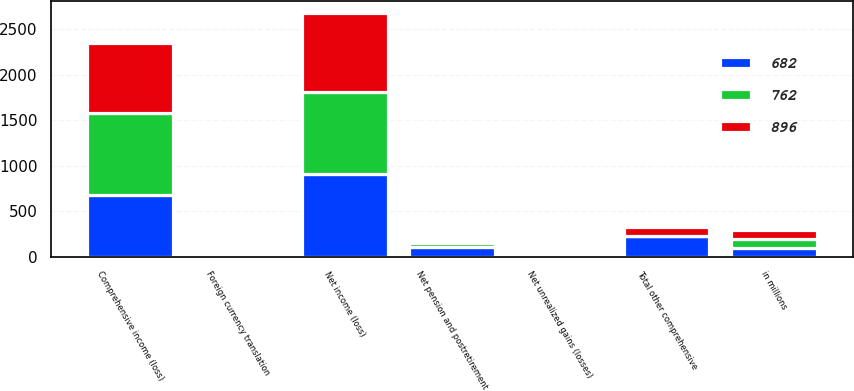Convert chart to OTSL. <chart><loc_0><loc_0><loc_500><loc_500><stacked_bar_chart><ecel><fcel>in millions<fcel>Net income (loss)<fcel>Net unrealized gains (losses)<fcel>Foreign currency translation<fcel>Net pension and postretirement<fcel>Total other comprehensive<fcel>Comprehensive income (loss)<nl><fcel>762<fcel>96<fcel>907<fcel>3<fcel>20<fcel>46<fcel>4<fcel>903<nl><fcel>682<fcel>96<fcel>910<fcel>29<fcel>13<fcel>106<fcel>228<fcel>682<nl><fcel>896<fcel>96<fcel>865<fcel>20<fcel>10<fcel>28<fcel>96<fcel>769<nl></chart> 